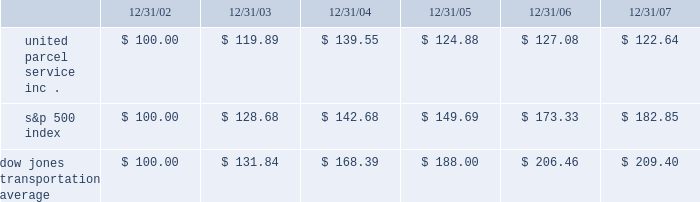Shareowner return performance graph the following performance graph and related information shall not be deemed 201csoliciting material 201d or to be 201cfiled 201d with the securities and exchange commission , nor shall such information be incorporated by reference into any future filing under the securities act of 1933 or securities exchange act of 1934 , each as amended , except to the extent that the company specifically incorporates such information by reference into such filing .
The following graph shows a five-year comparison of cumulative total shareowners 2019 returns for our class b common stock , the s&p 500 index , and the dow jones transportation average .
The comparison of the total cumulative return on investment , which is the change in the quarterly stock price plus reinvested dividends for each of the quarterly periods , assumes that $ 100 was invested on december 31 , 2002 in the s&p 500 index , the dow jones transportation average , and the class b common stock of united parcel service , inc .
Comparison of five year cumulative total return $ 40.00 $ 60.00 $ 80.00 $ 100.00 $ 120.00 $ 140.00 $ 160.00 $ 180.00 $ 200.00 $ 220.00 2002 20072006200520042003 s&p 500 ups dj transport .
Securities authorized for issuance under equity compensation plans the following table provides information as of december 31 , 2007 regarding compensation plans under which our class a common stock is authorized for issuance .
These plans do not authorize the issuance of our class b common stock. .
What is the rate of return of an investment in ups from 2003 to 2004? 
Computations: ((139.55 - 119.89) / 119.89)
Answer: 0.16398. 